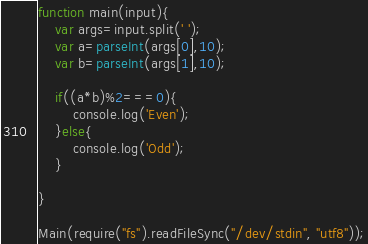Convert code to text. <code><loc_0><loc_0><loc_500><loc_500><_JavaScript_>function main(input){
	var args=input.split(' ');
	var a=parseInt(args[0],10);
	var b=parseInt(args[1],10);
	
	if((a*b)%2===0){
		console.log('Even');
	}else{
		console.log('Odd');
	}
		
}

Main(require("fs").readFileSync("/dev/stdin", "utf8"));</code> 